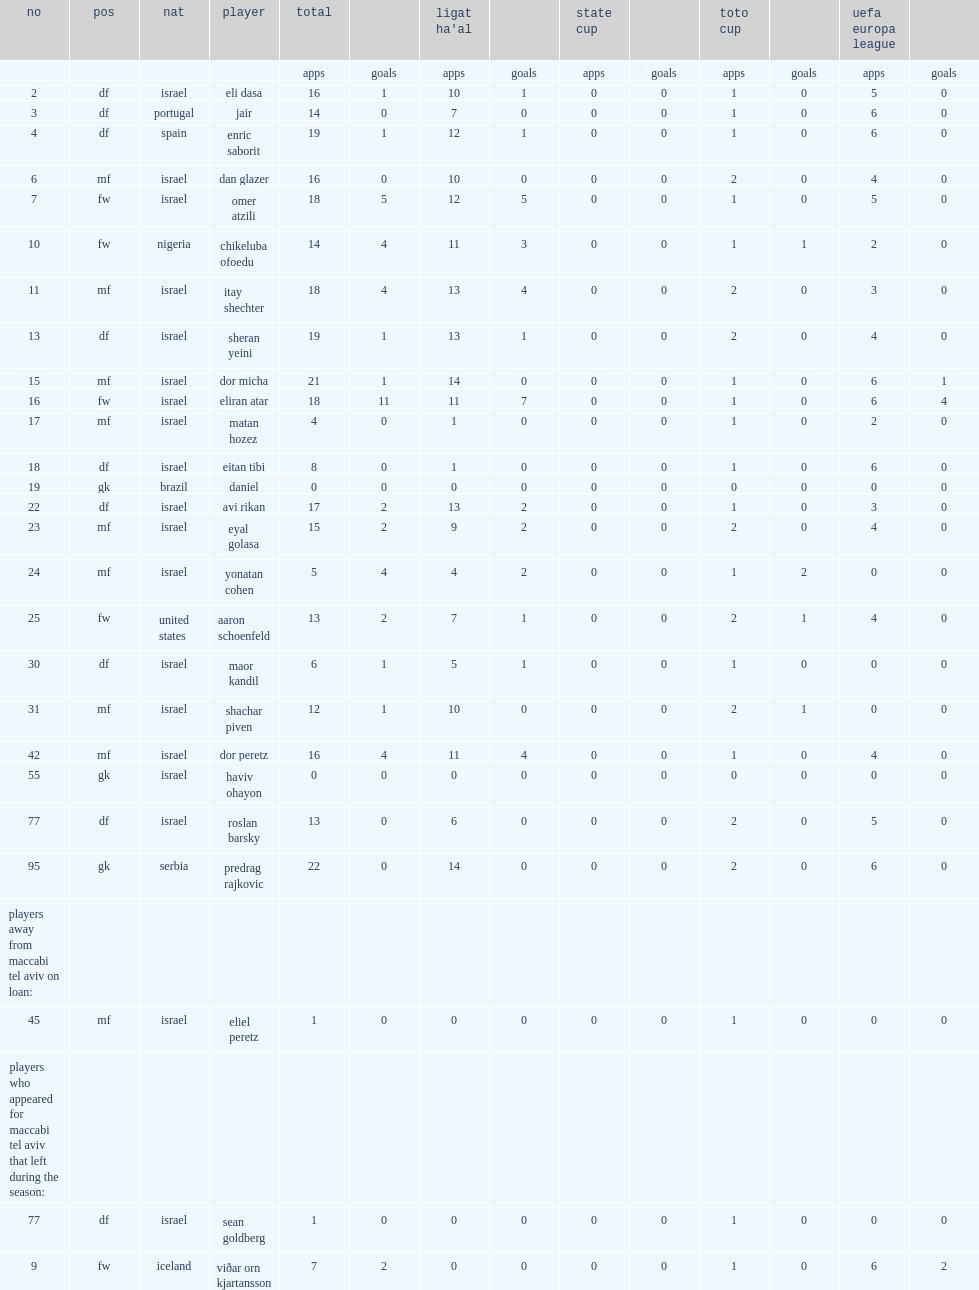List the matches that maccabi tel aviv have competed in. State cup toto cup uefa europa league. 